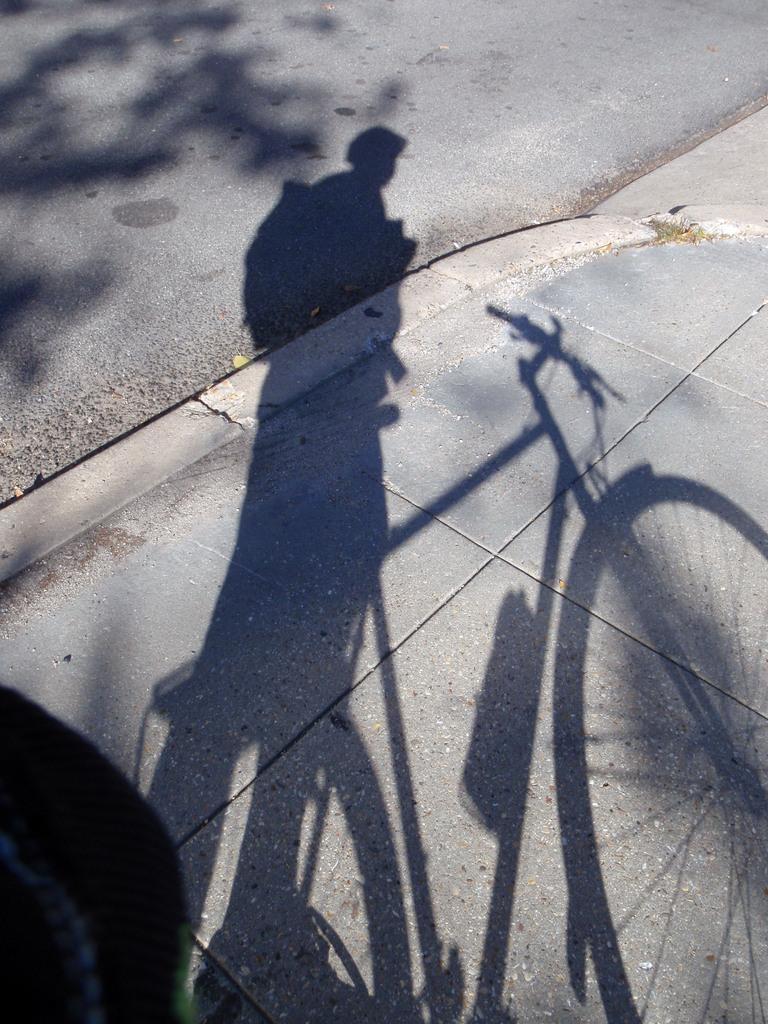Can you describe this image briefly? In this image we can see the shadow of a person, a bicycle and a tree on the ground. There is an object at the left side of the image. 